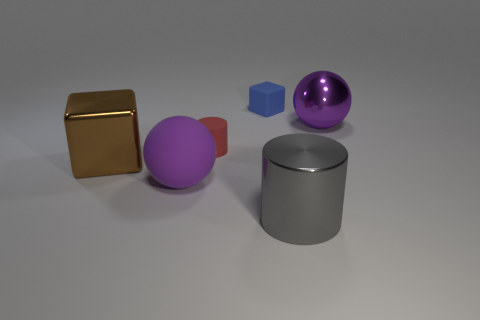Add 1 large metallic cubes. How many objects exist? 7 Subtract all blocks. How many objects are left? 4 Subtract all red matte cylinders. Subtract all metal cubes. How many objects are left? 4 Add 5 gray shiny cylinders. How many gray shiny cylinders are left? 6 Add 5 purple rubber spheres. How many purple rubber spheres exist? 6 Subtract 0 cyan blocks. How many objects are left? 6 